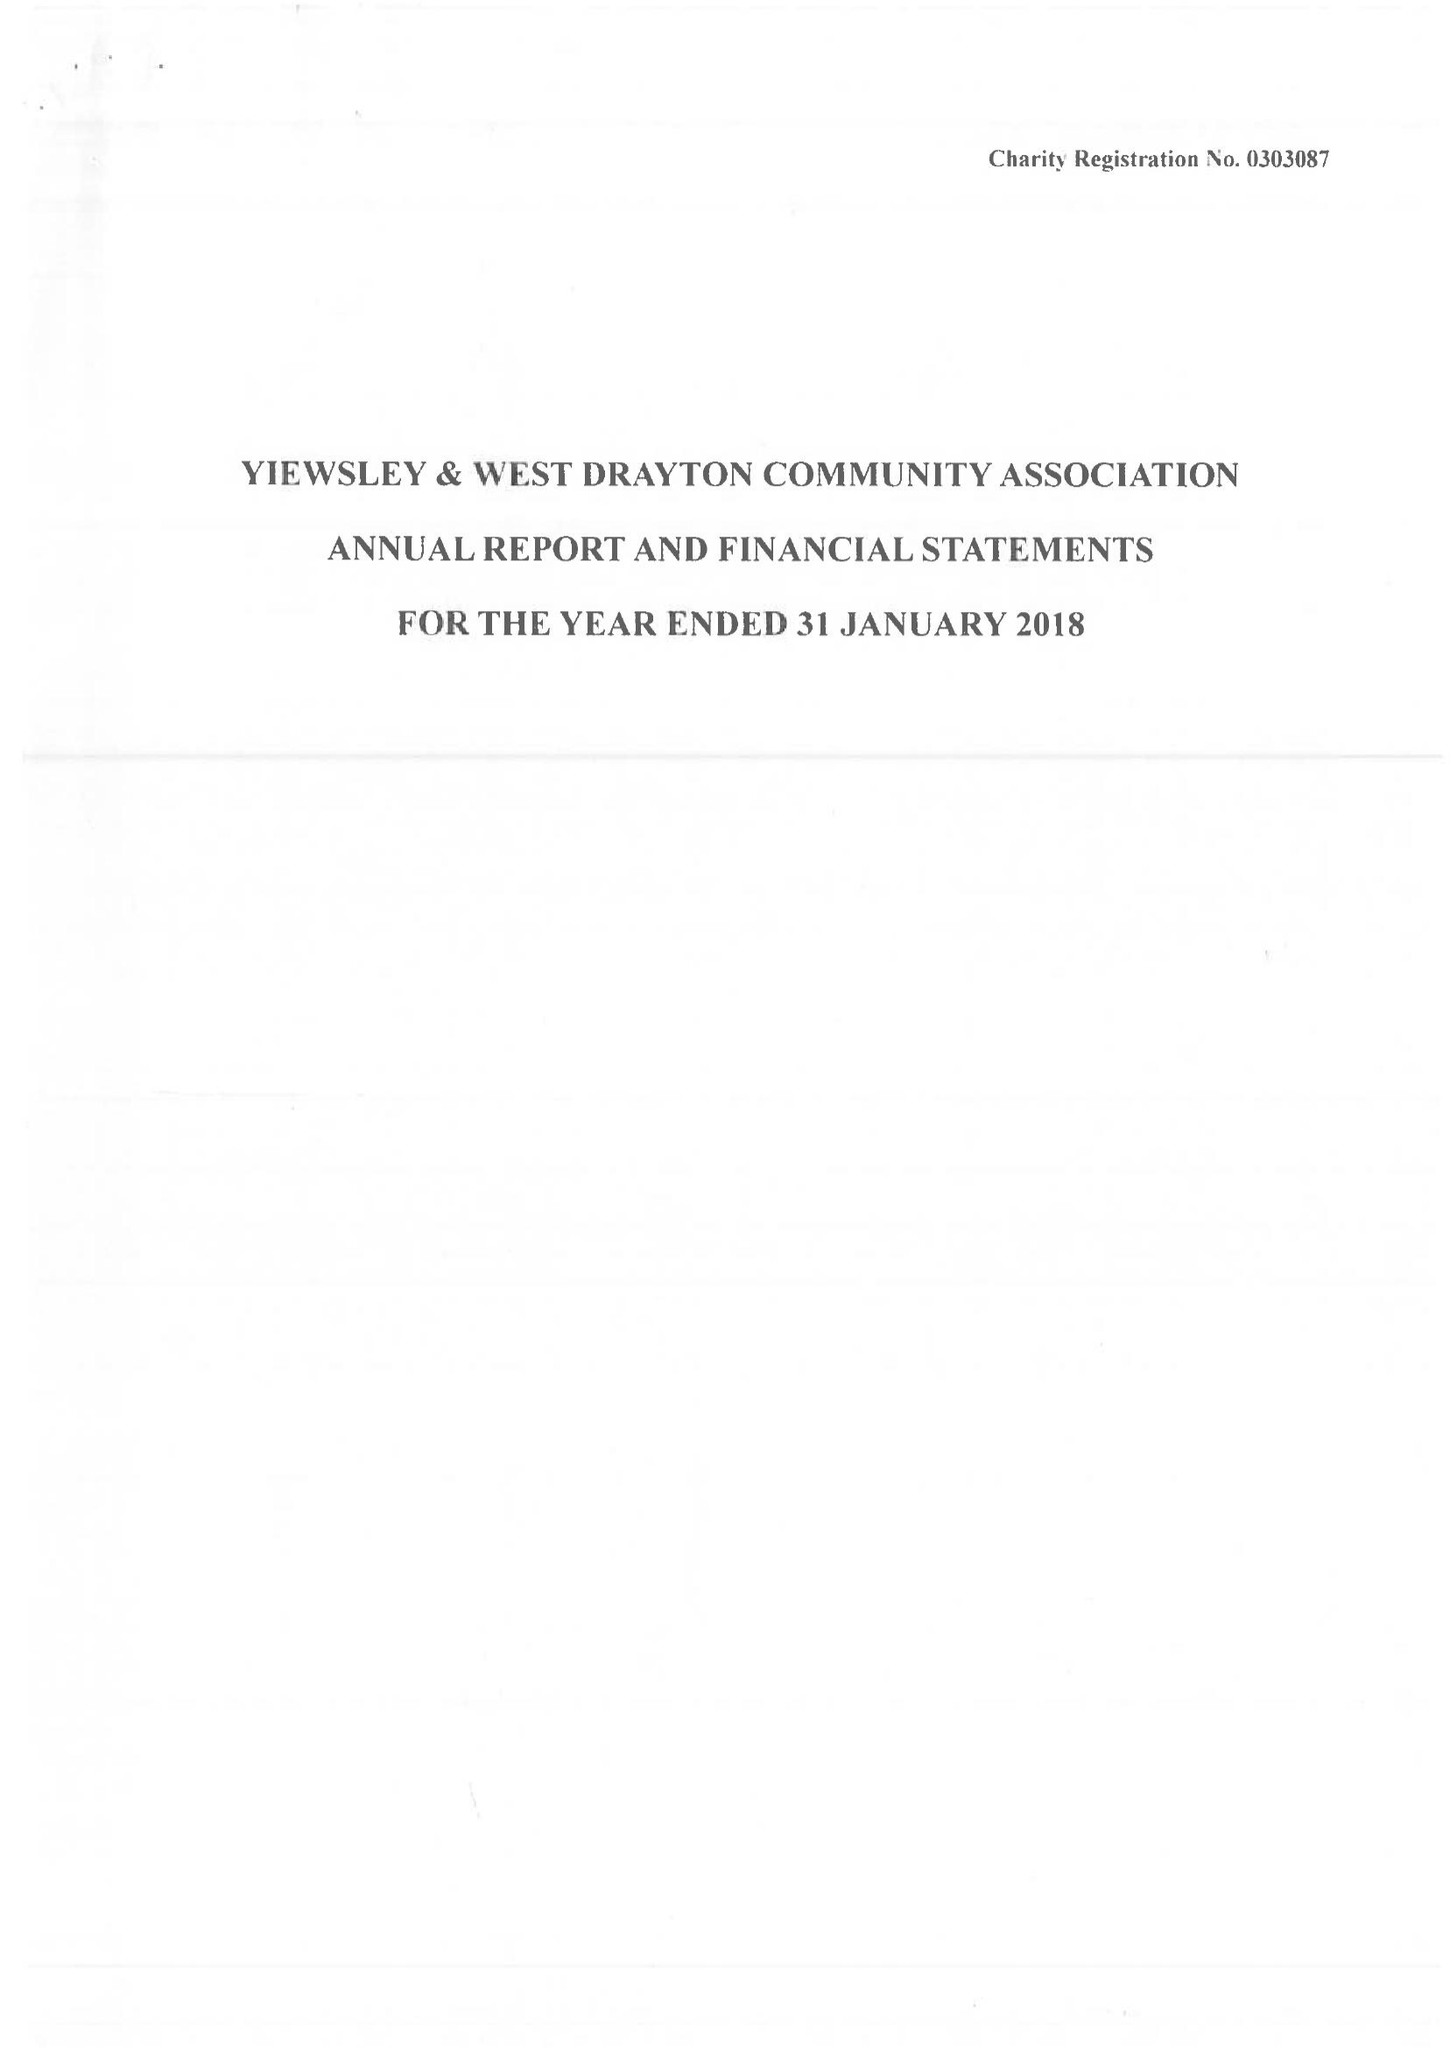What is the value for the address__postcode?
Answer the question using a single word or phrase. UB7 9JL 